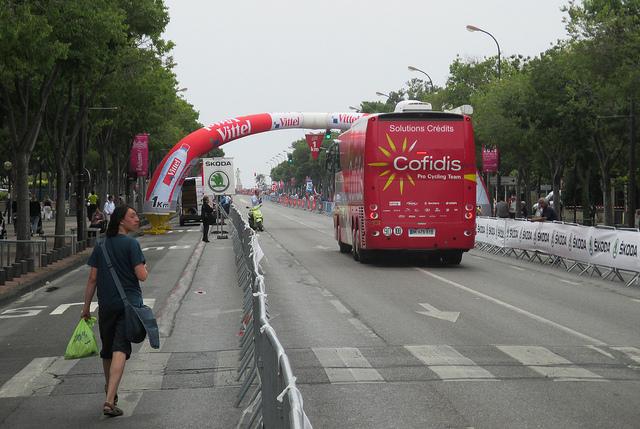What is the bus about to go under?
Give a very brief answer. Arch. What color is the bus?
Concise answer only. Red. Where is the bus?
Concise answer only. Road. 